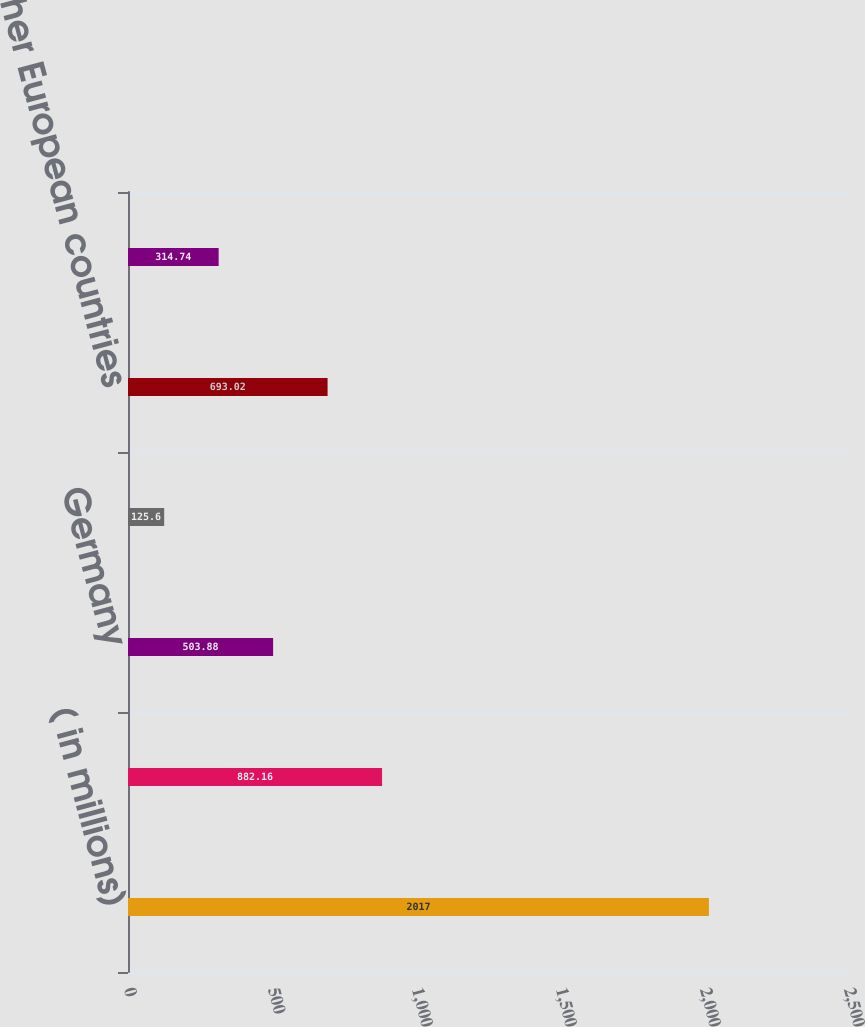<chart> <loc_0><loc_0><loc_500><loc_500><bar_chart><fcel>( in millions)<fcel>United States<fcel>Germany<fcel>France<fcel>Other European countries<fcel>Other<nl><fcel>2017<fcel>882.16<fcel>503.88<fcel>125.6<fcel>693.02<fcel>314.74<nl></chart> 